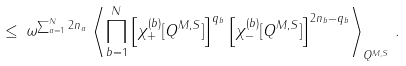<formula> <loc_0><loc_0><loc_500><loc_500>\leq \, \omega ^ { \sum _ { a = 1 } ^ { N } 2 n _ { a } } \, \left \langle \prod _ { b = 1 } ^ { N } \left [ \chi ^ { ( b ) } _ { + } [ Q ^ { M , S } ] \right ] ^ { q _ { b } } \left [ \chi ^ { ( b ) } _ { - } [ Q ^ { M , S } ] \right ] ^ { 2 n _ { b } - q _ { b } } \right \rangle _ { Q ^ { M , S } } \, .</formula> 